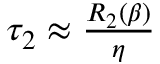<formula> <loc_0><loc_0><loc_500><loc_500>\begin{array} { r } { \tau _ { 2 } \approx \frac { R _ { 2 } ( \beta ) } { \eta } } \end{array}</formula> 